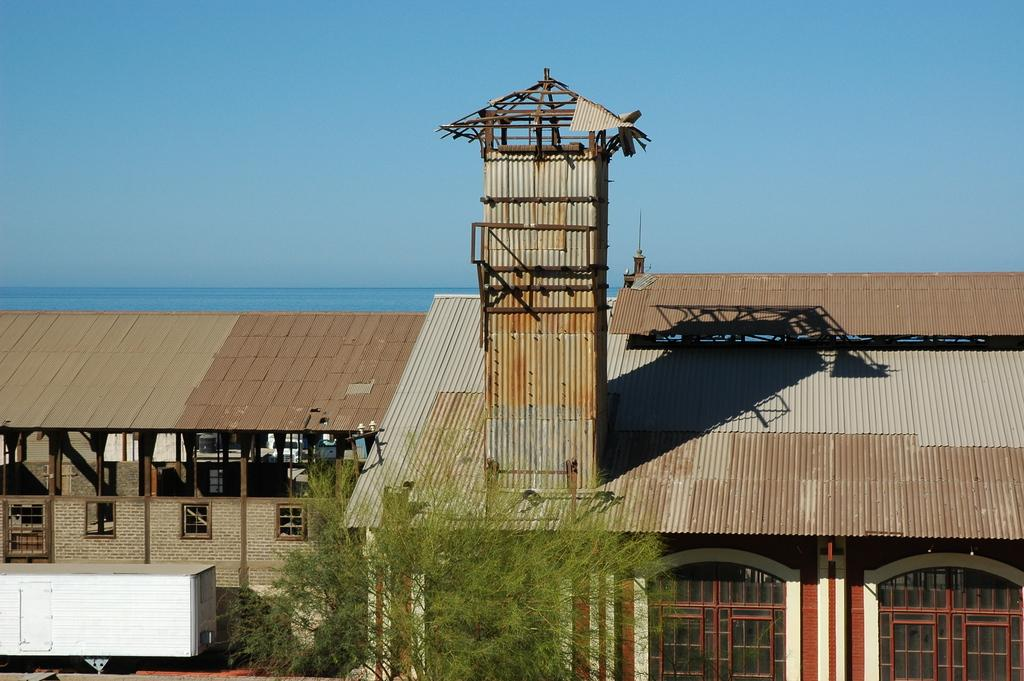What type of structures can be seen in the image? There are sheds in the image. What is located in front of the sheds? There is a container in front of the sheds. What type of vegetation is present in the image? There are trees in the image. What color is the sky in the background of the image? The sky is blue in the background of the image. Can you tell me how many ants are crawling on the sheds in the image? There are no ants present in the image; it only features sheds, a container, trees, and a blue sky. What advice would the grandfather give about the sheds in the image? There is no grandfather present in the image, nor is there any indication of advice being given. 